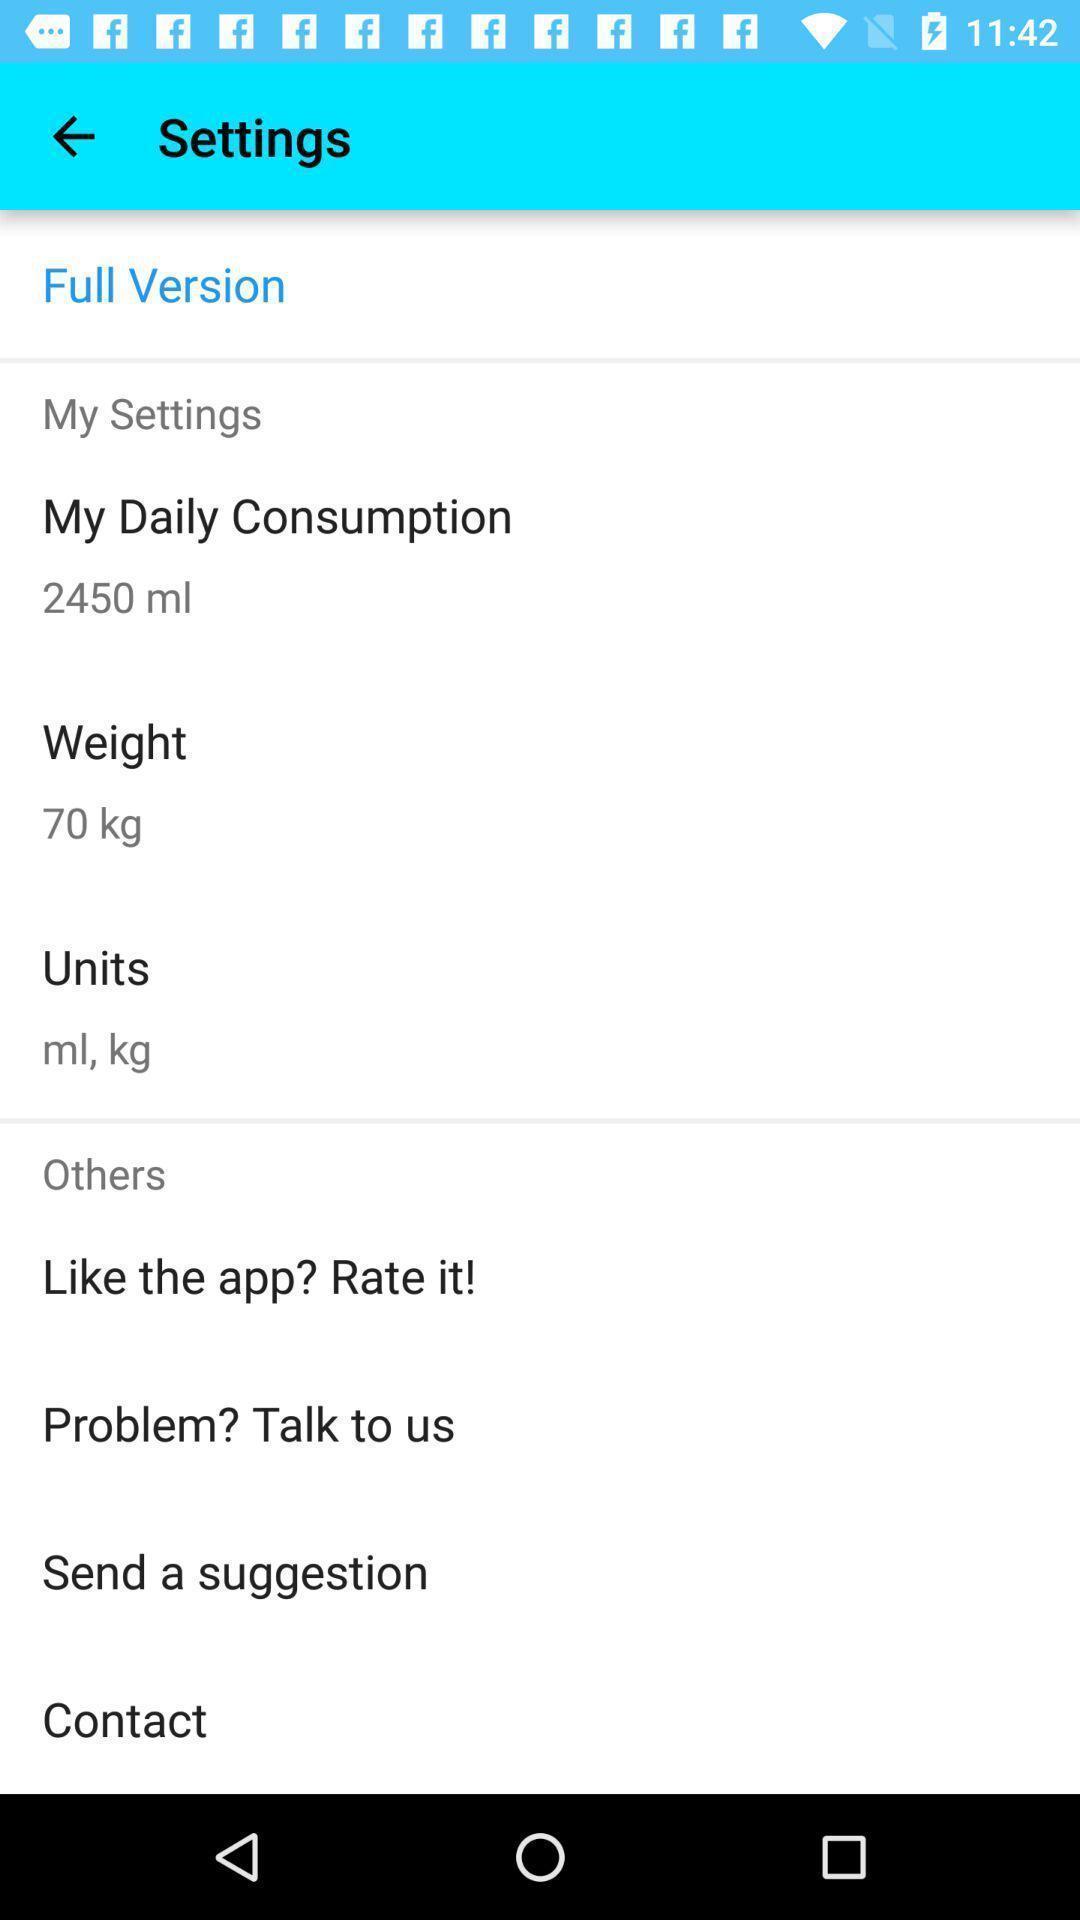Describe the content in this image. Settings page in a water reminder app. 